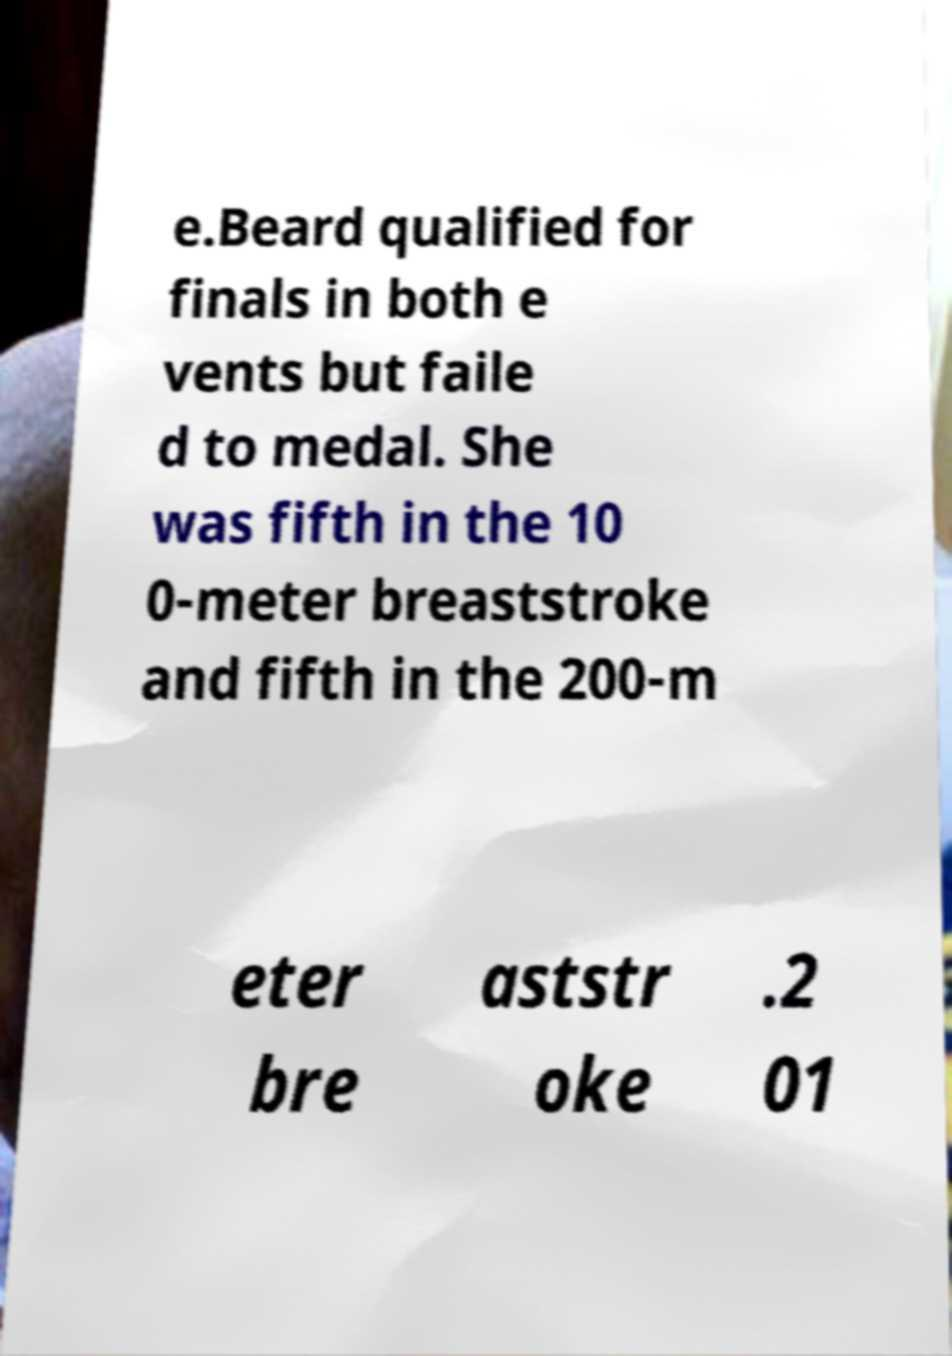Can you read and provide the text displayed in the image?This photo seems to have some interesting text. Can you extract and type it out for me? e.Beard qualified for finals in both e vents but faile d to medal. She was fifth in the 10 0-meter breaststroke and fifth in the 200-m eter bre aststr oke .2 01 